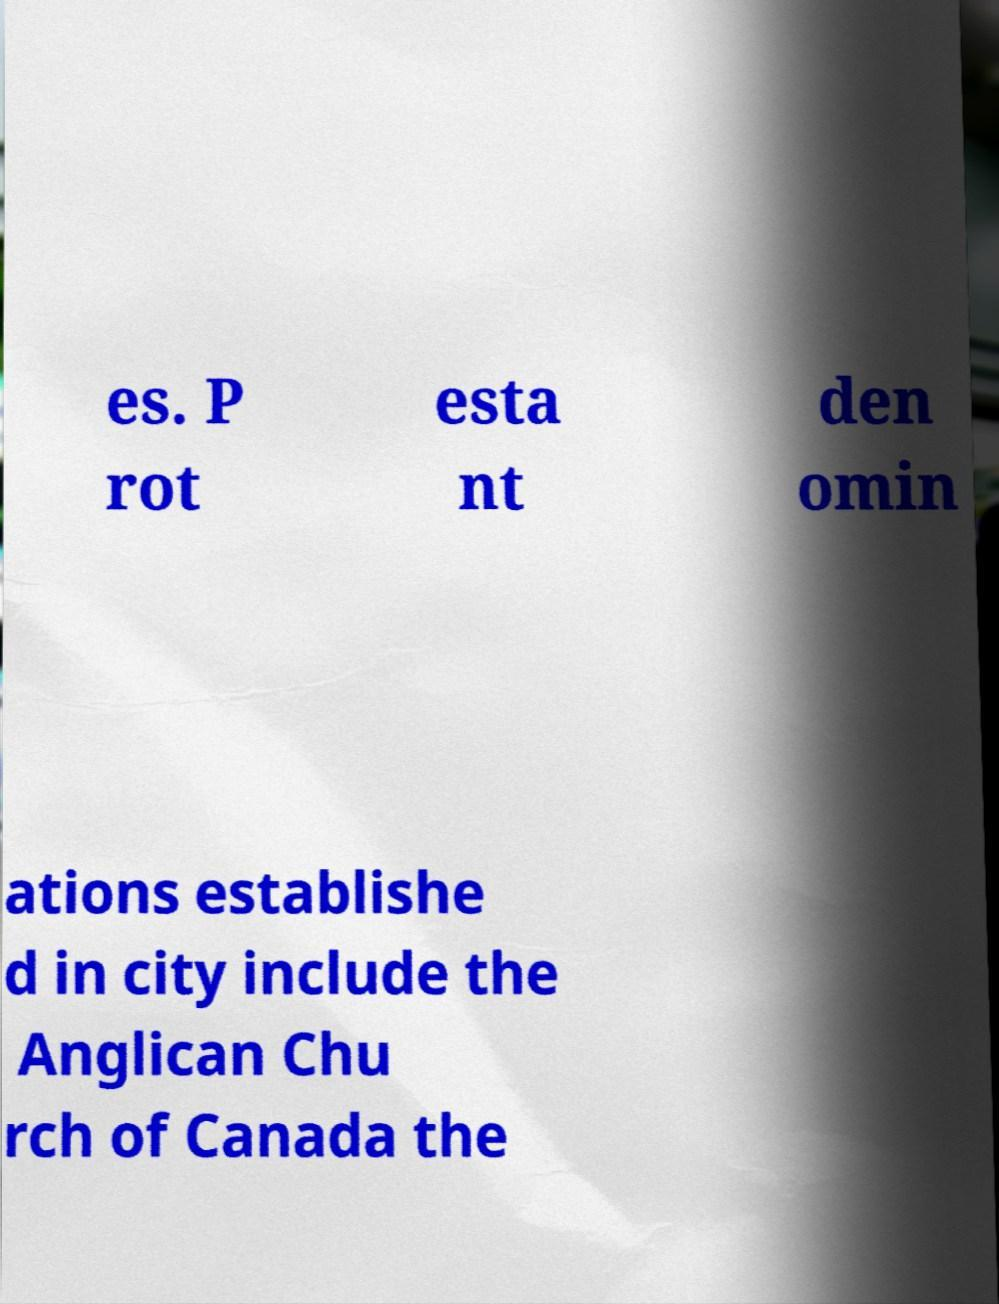Can you read and provide the text displayed in the image?This photo seems to have some interesting text. Can you extract and type it out for me? es. P rot esta nt den omin ations establishe d in city include the Anglican Chu rch of Canada the 